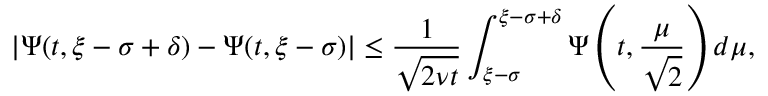Convert formula to latex. <formula><loc_0><loc_0><loc_500><loc_500>| \Psi ( t , \xi - \sigma + \delta ) - \Psi ( t , \xi - \sigma ) | \leq \frac { 1 } { \sqrt { 2 \nu t } } \int _ { \xi - \sigma } ^ { \xi - \sigma + \delta } \Psi \left ( t , \frac { \mu } { \sqrt { 2 } } \right ) d \mu ,</formula> 